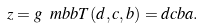<formula> <loc_0><loc_0><loc_500><loc_500>z = g ^ { \ } m b b T ( d , c , b ) = d c b a .</formula> 